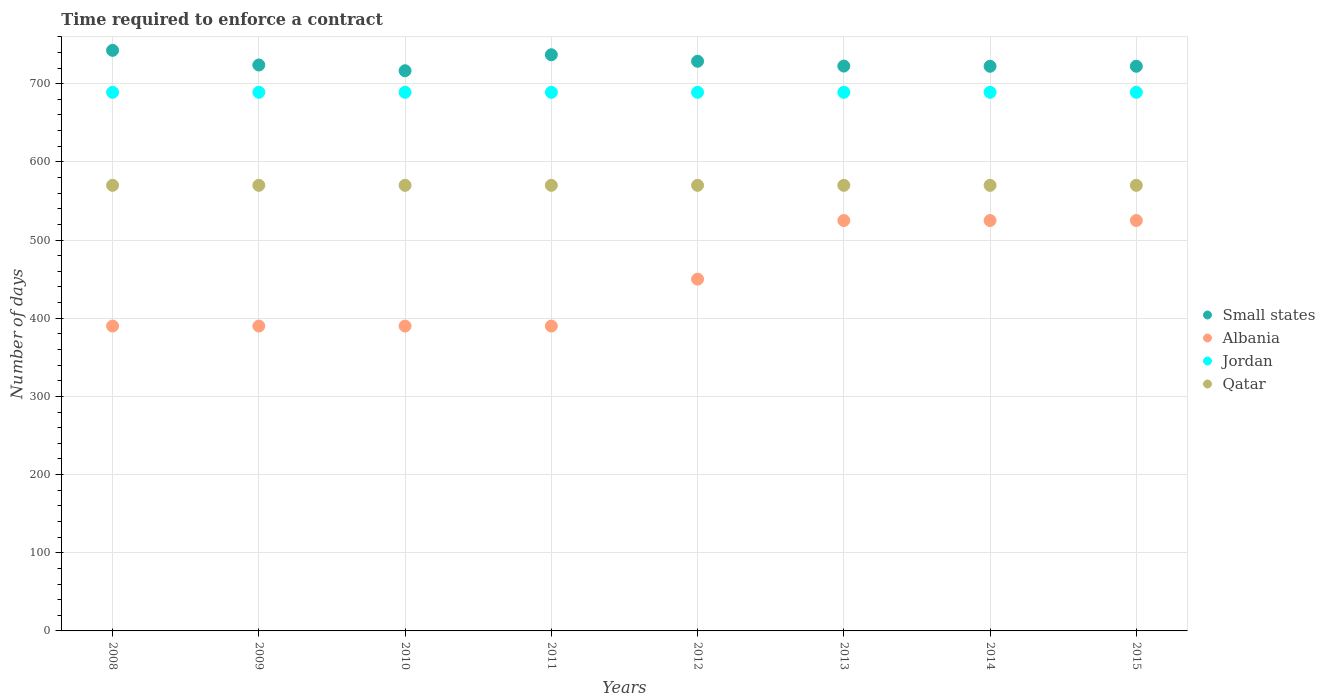How many different coloured dotlines are there?
Offer a terse response. 4. What is the number of days required to enforce a contract in Albania in 2011?
Make the answer very short. 390. Across all years, what is the maximum number of days required to enforce a contract in Jordan?
Provide a short and direct response. 689. Across all years, what is the minimum number of days required to enforce a contract in Qatar?
Your response must be concise. 570. In which year was the number of days required to enforce a contract in Albania minimum?
Offer a very short reply. 2008. What is the total number of days required to enforce a contract in Qatar in the graph?
Offer a terse response. 4560. What is the difference between the number of days required to enforce a contract in Qatar in 2009 and that in 2014?
Keep it short and to the point. 0. What is the difference between the number of days required to enforce a contract in Small states in 2013 and the number of days required to enforce a contract in Jordan in 2009?
Keep it short and to the point. 33.58. What is the average number of days required to enforce a contract in Albania per year?
Give a very brief answer. 448.12. In the year 2009, what is the difference between the number of days required to enforce a contract in Albania and number of days required to enforce a contract in Jordan?
Keep it short and to the point. -299. In how many years, is the number of days required to enforce a contract in Small states greater than 120 days?
Provide a short and direct response. 8. What is the ratio of the number of days required to enforce a contract in Qatar in 2009 to that in 2013?
Give a very brief answer. 1. What is the difference between the highest and the second highest number of days required to enforce a contract in Small states?
Ensure brevity in your answer.  5.62. What is the difference between the highest and the lowest number of days required to enforce a contract in Small states?
Your answer should be very brief. 26.08. In how many years, is the number of days required to enforce a contract in Qatar greater than the average number of days required to enforce a contract in Qatar taken over all years?
Your response must be concise. 0. Does the number of days required to enforce a contract in Jordan monotonically increase over the years?
Your answer should be compact. No. Is the number of days required to enforce a contract in Qatar strictly greater than the number of days required to enforce a contract in Albania over the years?
Offer a very short reply. Yes. How many dotlines are there?
Make the answer very short. 4. What is the difference between two consecutive major ticks on the Y-axis?
Ensure brevity in your answer.  100. Does the graph contain grids?
Your answer should be compact. Yes. Where does the legend appear in the graph?
Provide a short and direct response. Center right. How are the legend labels stacked?
Offer a terse response. Vertical. What is the title of the graph?
Give a very brief answer. Time required to enforce a contract. Does "Cambodia" appear as one of the legend labels in the graph?
Your response must be concise. No. What is the label or title of the X-axis?
Offer a very short reply. Years. What is the label or title of the Y-axis?
Give a very brief answer. Number of days. What is the Number of days of Small states in 2008?
Provide a short and direct response. 742.67. What is the Number of days of Albania in 2008?
Offer a very short reply. 390. What is the Number of days of Jordan in 2008?
Your answer should be compact. 689. What is the Number of days of Qatar in 2008?
Offer a very short reply. 570. What is the Number of days in Small states in 2009?
Give a very brief answer. 723.95. What is the Number of days in Albania in 2009?
Make the answer very short. 390. What is the Number of days in Jordan in 2009?
Provide a succinct answer. 689. What is the Number of days in Qatar in 2009?
Offer a very short reply. 570. What is the Number of days of Small states in 2010?
Offer a terse response. 716.59. What is the Number of days in Albania in 2010?
Keep it short and to the point. 390. What is the Number of days of Jordan in 2010?
Your answer should be very brief. 689. What is the Number of days in Qatar in 2010?
Your response must be concise. 570. What is the Number of days of Small states in 2011?
Your response must be concise. 737.05. What is the Number of days of Albania in 2011?
Make the answer very short. 390. What is the Number of days in Jordan in 2011?
Offer a terse response. 689. What is the Number of days of Qatar in 2011?
Offer a very short reply. 570. What is the Number of days of Small states in 2012?
Your response must be concise. 728.73. What is the Number of days of Albania in 2012?
Provide a succinct answer. 450. What is the Number of days in Jordan in 2012?
Your answer should be very brief. 689. What is the Number of days of Qatar in 2012?
Your response must be concise. 570. What is the Number of days of Small states in 2013?
Keep it short and to the point. 722.58. What is the Number of days in Albania in 2013?
Your response must be concise. 525. What is the Number of days of Jordan in 2013?
Provide a short and direct response. 689. What is the Number of days in Qatar in 2013?
Your answer should be compact. 570. What is the Number of days of Small states in 2014?
Your answer should be very brief. 722.33. What is the Number of days of Albania in 2014?
Offer a very short reply. 525. What is the Number of days of Jordan in 2014?
Your response must be concise. 689. What is the Number of days of Qatar in 2014?
Give a very brief answer. 570. What is the Number of days of Small states in 2015?
Give a very brief answer. 722.33. What is the Number of days of Albania in 2015?
Offer a terse response. 525. What is the Number of days in Jordan in 2015?
Your answer should be compact. 689. What is the Number of days of Qatar in 2015?
Your answer should be compact. 570. Across all years, what is the maximum Number of days of Small states?
Keep it short and to the point. 742.67. Across all years, what is the maximum Number of days in Albania?
Offer a very short reply. 525. Across all years, what is the maximum Number of days in Jordan?
Provide a succinct answer. 689. Across all years, what is the maximum Number of days of Qatar?
Provide a succinct answer. 570. Across all years, what is the minimum Number of days in Small states?
Your answer should be very brief. 716.59. Across all years, what is the minimum Number of days in Albania?
Your answer should be compact. 390. Across all years, what is the minimum Number of days of Jordan?
Provide a short and direct response. 689. Across all years, what is the minimum Number of days of Qatar?
Keep it short and to the point. 570. What is the total Number of days in Small states in the graph?
Make the answer very short. 5816.21. What is the total Number of days in Albania in the graph?
Keep it short and to the point. 3585. What is the total Number of days of Jordan in the graph?
Your response must be concise. 5512. What is the total Number of days in Qatar in the graph?
Provide a succinct answer. 4560. What is the difference between the Number of days of Small states in 2008 and that in 2009?
Offer a very short reply. 18.72. What is the difference between the Number of days of Albania in 2008 and that in 2009?
Provide a short and direct response. 0. What is the difference between the Number of days of Jordan in 2008 and that in 2009?
Ensure brevity in your answer.  0. What is the difference between the Number of days of Qatar in 2008 and that in 2009?
Give a very brief answer. 0. What is the difference between the Number of days in Small states in 2008 and that in 2010?
Your answer should be compact. 26.08. What is the difference between the Number of days in Albania in 2008 and that in 2010?
Ensure brevity in your answer.  0. What is the difference between the Number of days of Jordan in 2008 and that in 2010?
Keep it short and to the point. 0. What is the difference between the Number of days of Qatar in 2008 and that in 2010?
Give a very brief answer. 0. What is the difference between the Number of days of Small states in 2008 and that in 2011?
Provide a succinct answer. 5.62. What is the difference between the Number of days in Albania in 2008 and that in 2011?
Your answer should be compact. 0. What is the difference between the Number of days of Qatar in 2008 and that in 2011?
Your answer should be very brief. 0. What is the difference between the Number of days of Small states in 2008 and that in 2012?
Your answer should be compact. 13.94. What is the difference between the Number of days in Albania in 2008 and that in 2012?
Make the answer very short. -60. What is the difference between the Number of days in Jordan in 2008 and that in 2012?
Your response must be concise. 0. What is the difference between the Number of days in Small states in 2008 and that in 2013?
Your response must be concise. 20.09. What is the difference between the Number of days of Albania in 2008 and that in 2013?
Make the answer very short. -135. What is the difference between the Number of days in Qatar in 2008 and that in 2013?
Offer a very short reply. 0. What is the difference between the Number of days of Small states in 2008 and that in 2014?
Offer a terse response. 20.34. What is the difference between the Number of days of Albania in 2008 and that in 2014?
Your answer should be very brief. -135. What is the difference between the Number of days of Small states in 2008 and that in 2015?
Provide a short and direct response. 20.34. What is the difference between the Number of days of Albania in 2008 and that in 2015?
Offer a very short reply. -135. What is the difference between the Number of days of Jordan in 2008 and that in 2015?
Provide a short and direct response. 0. What is the difference between the Number of days of Qatar in 2008 and that in 2015?
Provide a succinct answer. 0. What is the difference between the Number of days in Small states in 2009 and that in 2010?
Provide a short and direct response. 7.36. What is the difference between the Number of days in Albania in 2009 and that in 2010?
Your response must be concise. 0. What is the difference between the Number of days in Jordan in 2009 and that in 2010?
Your response must be concise. 0. What is the difference between the Number of days in Small states in 2009 and that in 2011?
Keep it short and to the point. -13.1. What is the difference between the Number of days in Albania in 2009 and that in 2011?
Ensure brevity in your answer.  0. What is the difference between the Number of days in Qatar in 2009 and that in 2011?
Provide a succinct answer. 0. What is the difference between the Number of days in Small states in 2009 and that in 2012?
Give a very brief answer. -4.78. What is the difference between the Number of days in Albania in 2009 and that in 2012?
Provide a short and direct response. -60. What is the difference between the Number of days in Small states in 2009 and that in 2013?
Your response must be concise. 1.37. What is the difference between the Number of days in Albania in 2009 and that in 2013?
Your answer should be very brief. -135. What is the difference between the Number of days of Small states in 2009 and that in 2014?
Your answer should be compact. 1.62. What is the difference between the Number of days in Albania in 2009 and that in 2014?
Provide a short and direct response. -135. What is the difference between the Number of days in Qatar in 2009 and that in 2014?
Your answer should be compact. 0. What is the difference between the Number of days in Small states in 2009 and that in 2015?
Keep it short and to the point. 1.62. What is the difference between the Number of days in Albania in 2009 and that in 2015?
Ensure brevity in your answer.  -135. What is the difference between the Number of days of Jordan in 2009 and that in 2015?
Offer a terse response. 0. What is the difference between the Number of days in Qatar in 2009 and that in 2015?
Offer a very short reply. 0. What is the difference between the Number of days of Small states in 2010 and that in 2011?
Give a very brief answer. -20.46. What is the difference between the Number of days in Albania in 2010 and that in 2011?
Keep it short and to the point. 0. What is the difference between the Number of days of Jordan in 2010 and that in 2011?
Give a very brief answer. 0. What is the difference between the Number of days in Qatar in 2010 and that in 2011?
Make the answer very short. 0. What is the difference between the Number of days in Small states in 2010 and that in 2012?
Your answer should be compact. -12.14. What is the difference between the Number of days of Albania in 2010 and that in 2012?
Provide a short and direct response. -60. What is the difference between the Number of days of Jordan in 2010 and that in 2012?
Offer a terse response. 0. What is the difference between the Number of days in Qatar in 2010 and that in 2012?
Your answer should be very brief. 0. What is the difference between the Number of days of Small states in 2010 and that in 2013?
Offer a terse response. -5.99. What is the difference between the Number of days of Albania in 2010 and that in 2013?
Your answer should be compact. -135. What is the difference between the Number of days of Small states in 2010 and that in 2014?
Ensure brevity in your answer.  -5.74. What is the difference between the Number of days in Albania in 2010 and that in 2014?
Your answer should be very brief. -135. What is the difference between the Number of days of Jordan in 2010 and that in 2014?
Keep it short and to the point. 0. What is the difference between the Number of days of Qatar in 2010 and that in 2014?
Your answer should be very brief. 0. What is the difference between the Number of days of Small states in 2010 and that in 2015?
Make the answer very short. -5.74. What is the difference between the Number of days in Albania in 2010 and that in 2015?
Ensure brevity in your answer.  -135. What is the difference between the Number of days in Qatar in 2010 and that in 2015?
Offer a terse response. 0. What is the difference between the Number of days of Small states in 2011 and that in 2012?
Give a very brief answer. 8.32. What is the difference between the Number of days of Albania in 2011 and that in 2012?
Make the answer very short. -60. What is the difference between the Number of days of Qatar in 2011 and that in 2012?
Your response must be concise. 0. What is the difference between the Number of days in Small states in 2011 and that in 2013?
Your response must be concise. 14.47. What is the difference between the Number of days of Albania in 2011 and that in 2013?
Your response must be concise. -135. What is the difference between the Number of days of Jordan in 2011 and that in 2013?
Your answer should be very brief. 0. What is the difference between the Number of days of Qatar in 2011 and that in 2013?
Give a very brief answer. 0. What is the difference between the Number of days in Small states in 2011 and that in 2014?
Your response must be concise. 14.72. What is the difference between the Number of days of Albania in 2011 and that in 2014?
Offer a very short reply. -135. What is the difference between the Number of days in Jordan in 2011 and that in 2014?
Give a very brief answer. 0. What is the difference between the Number of days of Small states in 2011 and that in 2015?
Your answer should be very brief. 14.72. What is the difference between the Number of days in Albania in 2011 and that in 2015?
Make the answer very short. -135. What is the difference between the Number of days of Jordan in 2011 and that in 2015?
Provide a succinct answer. 0. What is the difference between the Number of days of Qatar in 2011 and that in 2015?
Make the answer very short. 0. What is the difference between the Number of days in Small states in 2012 and that in 2013?
Provide a short and direct response. 6.15. What is the difference between the Number of days in Albania in 2012 and that in 2013?
Offer a very short reply. -75. What is the difference between the Number of days of Small states in 2012 and that in 2014?
Provide a short and direct response. 6.4. What is the difference between the Number of days in Albania in 2012 and that in 2014?
Ensure brevity in your answer.  -75. What is the difference between the Number of days in Jordan in 2012 and that in 2014?
Your answer should be very brief. 0. What is the difference between the Number of days in Qatar in 2012 and that in 2014?
Ensure brevity in your answer.  0. What is the difference between the Number of days in Albania in 2012 and that in 2015?
Your response must be concise. -75. What is the difference between the Number of days in Jordan in 2013 and that in 2014?
Give a very brief answer. 0. What is the difference between the Number of days in Qatar in 2013 and that in 2014?
Provide a succinct answer. 0. What is the difference between the Number of days in Small states in 2013 and that in 2015?
Your answer should be very brief. 0.25. What is the difference between the Number of days in Qatar in 2013 and that in 2015?
Keep it short and to the point. 0. What is the difference between the Number of days of Small states in 2014 and that in 2015?
Offer a terse response. 0. What is the difference between the Number of days in Jordan in 2014 and that in 2015?
Your answer should be compact. 0. What is the difference between the Number of days of Qatar in 2014 and that in 2015?
Provide a succinct answer. 0. What is the difference between the Number of days of Small states in 2008 and the Number of days of Albania in 2009?
Your response must be concise. 352.67. What is the difference between the Number of days in Small states in 2008 and the Number of days in Jordan in 2009?
Make the answer very short. 53.67. What is the difference between the Number of days of Small states in 2008 and the Number of days of Qatar in 2009?
Provide a succinct answer. 172.67. What is the difference between the Number of days of Albania in 2008 and the Number of days of Jordan in 2009?
Your response must be concise. -299. What is the difference between the Number of days of Albania in 2008 and the Number of days of Qatar in 2009?
Keep it short and to the point. -180. What is the difference between the Number of days in Jordan in 2008 and the Number of days in Qatar in 2009?
Make the answer very short. 119. What is the difference between the Number of days in Small states in 2008 and the Number of days in Albania in 2010?
Provide a short and direct response. 352.67. What is the difference between the Number of days in Small states in 2008 and the Number of days in Jordan in 2010?
Provide a short and direct response. 53.67. What is the difference between the Number of days in Small states in 2008 and the Number of days in Qatar in 2010?
Offer a very short reply. 172.67. What is the difference between the Number of days in Albania in 2008 and the Number of days in Jordan in 2010?
Your answer should be very brief. -299. What is the difference between the Number of days in Albania in 2008 and the Number of days in Qatar in 2010?
Ensure brevity in your answer.  -180. What is the difference between the Number of days of Jordan in 2008 and the Number of days of Qatar in 2010?
Your answer should be very brief. 119. What is the difference between the Number of days in Small states in 2008 and the Number of days in Albania in 2011?
Offer a very short reply. 352.67. What is the difference between the Number of days of Small states in 2008 and the Number of days of Jordan in 2011?
Your response must be concise. 53.67. What is the difference between the Number of days of Small states in 2008 and the Number of days of Qatar in 2011?
Provide a short and direct response. 172.67. What is the difference between the Number of days in Albania in 2008 and the Number of days in Jordan in 2011?
Your answer should be compact. -299. What is the difference between the Number of days in Albania in 2008 and the Number of days in Qatar in 2011?
Your answer should be very brief. -180. What is the difference between the Number of days in Jordan in 2008 and the Number of days in Qatar in 2011?
Give a very brief answer. 119. What is the difference between the Number of days of Small states in 2008 and the Number of days of Albania in 2012?
Give a very brief answer. 292.67. What is the difference between the Number of days in Small states in 2008 and the Number of days in Jordan in 2012?
Provide a succinct answer. 53.67. What is the difference between the Number of days of Small states in 2008 and the Number of days of Qatar in 2012?
Offer a terse response. 172.67. What is the difference between the Number of days in Albania in 2008 and the Number of days in Jordan in 2012?
Your answer should be compact. -299. What is the difference between the Number of days in Albania in 2008 and the Number of days in Qatar in 2012?
Keep it short and to the point. -180. What is the difference between the Number of days in Jordan in 2008 and the Number of days in Qatar in 2012?
Your answer should be very brief. 119. What is the difference between the Number of days in Small states in 2008 and the Number of days in Albania in 2013?
Your answer should be compact. 217.67. What is the difference between the Number of days of Small states in 2008 and the Number of days of Jordan in 2013?
Make the answer very short. 53.67. What is the difference between the Number of days of Small states in 2008 and the Number of days of Qatar in 2013?
Provide a succinct answer. 172.67. What is the difference between the Number of days in Albania in 2008 and the Number of days in Jordan in 2013?
Offer a terse response. -299. What is the difference between the Number of days of Albania in 2008 and the Number of days of Qatar in 2013?
Offer a terse response. -180. What is the difference between the Number of days of Jordan in 2008 and the Number of days of Qatar in 2013?
Offer a terse response. 119. What is the difference between the Number of days of Small states in 2008 and the Number of days of Albania in 2014?
Provide a short and direct response. 217.67. What is the difference between the Number of days in Small states in 2008 and the Number of days in Jordan in 2014?
Offer a terse response. 53.67. What is the difference between the Number of days in Small states in 2008 and the Number of days in Qatar in 2014?
Your answer should be very brief. 172.67. What is the difference between the Number of days of Albania in 2008 and the Number of days of Jordan in 2014?
Your answer should be compact. -299. What is the difference between the Number of days in Albania in 2008 and the Number of days in Qatar in 2014?
Offer a terse response. -180. What is the difference between the Number of days in Jordan in 2008 and the Number of days in Qatar in 2014?
Your answer should be compact. 119. What is the difference between the Number of days of Small states in 2008 and the Number of days of Albania in 2015?
Your response must be concise. 217.67. What is the difference between the Number of days in Small states in 2008 and the Number of days in Jordan in 2015?
Make the answer very short. 53.67. What is the difference between the Number of days of Small states in 2008 and the Number of days of Qatar in 2015?
Your answer should be very brief. 172.67. What is the difference between the Number of days of Albania in 2008 and the Number of days of Jordan in 2015?
Your answer should be very brief. -299. What is the difference between the Number of days of Albania in 2008 and the Number of days of Qatar in 2015?
Keep it short and to the point. -180. What is the difference between the Number of days in Jordan in 2008 and the Number of days in Qatar in 2015?
Keep it short and to the point. 119. What is the difference between the Number of days of Small states in 2009 and the Number of days of Albania in 2010?
Keep it short and to the point. 333.95. What is the difference between the Number of days of Small states in 2009 and the Number of days of Jordan in 2010?
Offer a very short reply. 34.95. What is the difference between the Number of days in Small states in 2009 and the Number of days in Qatar in 2010?
Your response must be concise. 153.95. What is the difference between the Number of days in Albania in 2009 and the Number of days in Jordan in 2010?
Provide a succinct answer. -299. What is the difference between the Number of days in Albania in 2009 and the Number of days in Qatar in 2010?
Your answer should be very brief. -180. What is the difference between the Number of days in Jordan in 2009 and the Number of days in Qatar in 2010?
Ensure brevity in your answer.  119. What is the difference between the Number of days in Small states in 2009 and the Number of days in Albania in 2011?
Your response must be concise. 333.95. What is the difference between the Number of days in Small states in 2009 and the Number of days in Jordan in 2011?
Your answer should be very brief. 34.95. What is the difference between the Number of days in Small states in 2009 and the Number of days in Qatar in 2011?
Make the answer very short. 153.95. What is the difference between the Number of days in Albania in 2009 and the Number of days in Jordan in 2011?
Provide a short and direct response. -299. What is the difference between the Number of days in Albania in 2009 and the Number of days in Qatar in 2011?
Make the answer very short. -180. What is the difference between the Number of days of Jordan in 2009 and the Number of days of Qatar in 2011?
Your response must be concise. 119. What is the difference between the Number of days in Small states in 2009 and the Number of days in Albania in 2012?
Ensure brevity in your answer.  273.95. What is the difference between the Number of days in Small states in 2009 and the Number of days in Jordan in 2012?
Your response must be concise. 34.95. What is the difference between the Number of days in Small states in 2009 and the Number of days in Qatar in 2012?
Offer a terse response. 153.95. What is the difference between the Number of days in Albania in 2009 and the Number of days in Jordan in 2012?
Provide a succinct answer. -299. What is the difference between the Number of days in Albania in 2009 and the Number of days in Qatar in 2012?
Give a very brief answer. -180. What is the difference between the Number of days of Jordan in 2009 and the Number of days of Qatar in 2012?
Your answer should be compact. 119. What is the difference between the Number of days of Small states in 2009 and the Number of days of Albania in 2013?
Offer a very short reply. 198.95. What is the difference between the Number of days in Small states in 2009 and the Number of days in Jordan in 2013?
Provide a succinct answer. 34.95. What is the difference between the Number of days of Small states in 2009 and the Number of days of Qatar in 2013?
Your response must be concise. 153.95. What is the difference between the Number of days of Albania in 2009 and the Number of days of Jordan in 2013?
Your response must be concise. -299. What is the difference between the Number of days of Albania in 2009 and the Number of days of Qatar in 2013?
Provide a succinct answer. -180. What is the difference between the Number of days of Jordan in 2009 and the Number of days of Qatar in 2013?
Ensure brevity in your answer.  119. What is the difference between the Number of days of Small states in 2009 and the Number of days of Albania in 2014?
Offer a terse response. 198.95. What is the difference between the Number of days of Small states in 2009 and the Number of days of Jordan in 2014?
Ensure brevity in your answer.  34.95. What is the difference between the Number of days of Small states in 2009 and the Number of days of Qatar in 2014?
Keep it short and to the point. 153.95. What is the difference between the Number of days of Albania in 2009 and the Number of days of Jordan in 2014?
Give a very brief answer. -299. What is the difference between the Number of days in Albania in 2009 and the Number of days in Qatar in 2014?
Offer a terse response. -180. What is the difference between the Number of days in Jordan in 2009 and the Number of days in Qatar in 2014?
Your answer should be very brief. 119. What is the difference between the Number of days of Small states in 2009 and the Number of days of Albania in 2015?
Offer a terse response. 198.95. What is the difference between the Number of days in Small states in 2009 and the Number of days in Jordan in 2015?
Make the answer very short. 34.95. What is the difference between the Number of days in Small states in 2009 and the Number of days in Qatar in 2015?
Make the answer very short. 153.95. What is the difference between the Number of days in Albania in 2009 and the Number of days in Jordan in 2015?
Your response must be concise. -299. What is the difference between the Number of days of Albania in 2009 and the Number of days of Qatar in 2015?
Offer a terse response. -180. What is the difference between the Number of days in Jordan in 2009 and the Number of days in Qatar in 2015?
Offer a very short reply. 119. What is the difference between the Number of days in Small states in 2010 and the Number of days in Albania in 2011?
Your answer should be very brief. 326.59. What is the difference between the Number of days in Small states in 2010 and the Number of days in Jordan in 2011?
Offer a terse response. 27.59. What is the difference between the Number of days in Small states in 2010 and the Number of days in Qatar in 2011?
Make the answer very short. 146.59. What is the difference between the Number of days in Albania in 2010 and the Number of days in Jordan in 2011?
Offer a terse response. -299. What is the difference between the Number of days in Albania in 2010 and the Number of days in Qatar in 2011?
Keep it short and to the point. -180. What is the difference between the Number of days in Jordan in 2010 and the Number of days in Qatar in 2011?
Keep it short and to the point. 119. What is the difference between the Number of days of Small states in 2010 and the Number of days of Albania in 2012?
Your response must be concise. 266.59. What is the difference between the Number of days of Small states in 2010 and the Number of days of Jordan in 2012?
Ensure brevity in your answer.  27.59. What is the difference between the Number of days of Small states in 2010 and the Number of days of Qatar in 2012?
Ensure brevity in your answer.  146.59. What is the difference between the Number of days of Albania in 2010 and the Number of days of Jordan in 2012?
Offer a terse response. -299. What is the difference between the Number of days of Albania in 2010 and the Number of days of Qatar in 2012?
Give a very brief answer. -180. What is the difference between the Number of days in Jordan in 2010 and the Number of days in Qatar in 2012?
Provide a succinct answer. 119. What is the difference between the Number of days in Small states in 2010 and the Number of days in Albania in 2013?
Keep it short and to the point. 191.59. What is the difference between the Number of days in Small states in 2010 and the Number of days in Jordan in 2013?
Give a very brief answer. 27.59. What is the difference between the Number of days of Small states in 2010 and the Number of days of Qatar in 2013?
Your response must be concise. 146.59. What is the difference between the Number of days in Albania in 2010 and the Number of days in Jordan in 2013?
Provide a succinct answer. -299. What is the difference between the Number of days in Albania in 2010 and the Number of days in Qatar in 2013?
Keep it short and to the point. -180. What is the difference between the Number of days of Jordan in 2010 and the Number of days of Qatar in 2013?
Your answer should be very brief. 119. What is the difference between the Number of days of Small states in 2010 and the Number of days of Albania in 2014?
Offer a very short reply. 191.59. What is the difference between the Number of days in Small states in 2010 and the Number of days in Jordan in 2014?
Offer a terse response. 27.59. What is the difference between the Number of days in Small states in 2010 and the Number of days in Qatar in 2014?
Your response must be concise. 146.59. What is the difference between the Number of days of Albania in 2010 and the Number of days of Jordan in 2014?
Give a very brief answer. -299. What is the difference between the Number of days in Albania in 2010 and the Number of days in Qatar in 2014?
Your answer should be compact. -180. What is the difference between the Number of days of Jordan in 2010 and the Number of days of Qatar in 2014?
Make the answer very short. 119. What is the difference between the Number of days in Small states in 2010 and the Number of days in Albania in 2015?
Offer a terse response. 191.59. What is the difference between the Number of days of Small states in 2010 and the Number of days of Jordan in 2015?
Make the answer very short. 27.59. What is the difference between the Number of days of Small states in 2010 and the Number of days of Qatar in 2015?
Provide a succinct answer. 146.59. What is the difference between the Number of days in Albania in 2010 and the Number of days in Jordan in 2015?
Your response must be concise. -299. What is the difference between the Number of days in Albania in 2010 and the Number of days in Qatar in 2015?
Ensure brevity in your answer.  -180. What is the difference between the Number of days in Jordan in 2010 and the Number of days in Qatar in 2015?
Your response must be concise. 119. What is the difference between the Number of days of Small states in 2011 and the Number of days of Albania in 2012?
Make the answer very short. 287.05. What is the difference between the Number of days in Small states in 2011 and the Number of days in Jordan in 2012?
Provide a succinct answer. 48.05. What is the difference between the Number of days in Small states in 2011 and the Number of days in Qatar in 2012?
Your answer should be very brief. 167.05. What is the difference between the Number of days of Albania in 2011 and the Number of days of Jordan in 2012?
Offer a terse response. -299. What is the difference between the Number of days of Albania in 2011 and the Number of days of Qatar in 2012?
Provide a short and direct response. -180. What is the difference between the Number of days in Jordan in 2011 and the Number of days in Qatar in 2012?
Provide a short and direct response. 119. What is the difference between the Number of days in Small states in 2011 and the Number of days in Albania in 2013?
Provide a succinct answer. 212.05. What is the difference between the Number of days of Small states in 2011 and the Number of days of Jordan in 2013?
Keep it short and to the point. 48.05. What is the difference between the Number of days of Small states in 2011 and the Number of days of Qatar in 2013?
Your answer should be very brief. 167.05. What is the difference between the Number of days in Albania in 2011 and the Number of days in Jordan in 2013?
Your answer should be very brief. -299. What is the difference between the Number of days in Albania in 2011 and the Number of days in Qatar in 2013?
Ensure brevity in your answer.  -180. What is the difference between the Number of days of Jordan in 2011 and the Number of days of Qatar in 2013?
Your answer should be compact. 119. What is the difference between the Number of days of Small states in 2011 and the Number of days of Albania in 2014?
Offer a terse response. 212.05. What is the difference between the Number of days of Small states in 2011 and the Number of days of Jordan in 2014?
Your answer should be very brief. 48.05. What is the difference between the Number of days in Small states in 2011 and the Number of days in Qatar in 2014?
Keep it short and to the point. 167.05. What is the difference between the Number of days in Albania in 2011 and the Number of days in Jordan in 2014?
Offer a very short reply. -299. What is the difference between the Number of days in Albania in 2011 and the Number of days in Qatar in 2014?
Keep it short and to the point. -180. What is the difference between the Number of days of Jordan in 2011 and the Number of days of Qatar in 2014?
Give a very brief answer. 119. What is the difference between the Number of days of Small states in 2011 and the Number of days of Albania in 2015?
Offer a terse response. 212.05. What is the difference between the Number of days in Small states in 2011 and the Number of days in Jordan in 2015?
Provide a succinct answer. 48.05. What is the difference between the Number of days of Small states in 2011 and the Number of days of Qatar in 2015?
Your answer should be compact. 167.05. What is the difference between the Number of days in Albania in 2011 and the Number of days in Jordan in 2015?
Your response must be concise. -299. What is the difference between the Number of days in Albania in 2011 and the Number of days in Qatar in 2015?
Give a very brief answer. -180. What is the difference between the Number of days in Jordan in 2011 and the Number of days in Qatar in 2015?
Your answer should be very brief. 119. What is the difference between the Number of days in Small states in 2012 and the Number of days in Albania in 2013?
Make the answer very short. 203.72. What is the difference between the Number of days of Small states in 2012 and the Number of days of Jordan in 2013?
Make the answer very short. 39.73. What is the difference between the Number of days in Small states in 2012 and the Number of days in Qatar in 2013?
Your answer should be very brief. 158.72. What is the difference between the Number of days of Albania in 2012 and the Number of days of Jordan in 2013?
Provide a succinct answer. -239. What is the difference between the Number of days in Albania in 2012 and the Number of days in Qatar in 2013?
Make the answer very short. -120. What is the difference between the Number of days in Jordan in 2012 and the Number of days in Qatar in 2013?
Give a very brief answer. 119. What is the difference between the Number of days of Small states in 2012 and the Number of days of Albania in 2014?
Keep it short and to the point. 203.72. What is the difference between the Number of days in Small states in 2012 and the Number of days in Jordan in 2014?
Give a very brief answer. 39.73. What is the difference between the Number of days of Small states in 2012 and the Number of days of Qatar in 2014?
Offer a terse response. 158.72. What is the difference between the Number of days in Albania in 2012 and the Number of days in Jordan in 2014?
Your answer should be very brief. -239. What is the difference between the Number of days of Albania in 2012 and the Number of days of Qatar in 2014?
Offer a very short reply. -120. What is the difference between the Number of days of Jordan in 2012 and the Number of days of Qatar in 2014?
Offer a terse response. 119. What is the difference between the Number of days in Small states in 2012 and the Number of days in Albania in 2015?
Give a very brief answer. 203.72. What is the difference between the Number of days of Small states in 2012 and the Number of days of Jordan in 2015?
Your answer should be compact. 39.73. What is the difference between the Number of days of Small states in 2012 and the Number of days of Qatar in 2015?
Your answer should be very brief. 158.72. What is the difference between the Number of days of Albania in 2012 and the Number of days of Jordan in 2015?
Give a very brief answer. -239. What is the difference between the Number of days of Albania in 2012 and the Number of days of Qatar in 2015?
Offer a very short reply. -120. What is the difference between the Number of days in Jordan in 2012 and the Number of days in Qatar in 2015?
Make the answer very short. 119. What is the difference between the Number of days in Small states in 2013 and the Number of days in Albania in 2014?
Provide a short and direct response. 197.57. What is the difference between the Number of days in Small states in 2013 and the Number of days in Jordan in 2014?
Provide a succinct answer. 33.58. What is the difference between the Number of days of Small states in 2013 and the Number of days of Qatar in 2014?
Make the answer very short. 152.57. What is the difference between the Number of days of Albania in 2013 and the Number of days of Jordan in 2014?
Your answer should be compact. -164. What is the difference between the Number of days in Albania in 2013 and the Number of days in Qatar in 2014?
Your response must be concise. -45. What is the difference between the Number of days of Jordan in 2013 and the Number of days of Qatar in 2014?
Offer a terse response. 119. What is the difference between the Number of days in Small states in 2013 and the Number of days in Albania in 2015?
Make the answer very short. 197.57. What is the difference between the Number of days of Small states in 2013 and the Number of days of Jordan in 2015?
Provide a succinct answer. 33.58. What is the difference between the Number of days in Small states in 2013 and the Number of days in Qatar in 2015?
Make the answer very short. 152.57. What is the difference between the Number of days in Albania in 2013 and the Number of days in Jordan in 2015?
Provide a short and direct response. -164. What is the difference between the Number of days of Albania in 2013 and the Number of days of Qatar in 2015?
Make the answer very short. -45. What is the difference between the Number of days in Jordan in 2013 and the Number of days in Qatar in 2015?
Your answer should be compact. 119. What is the difference between the Number of days in Small states in 2014 and the Number of days in Albania in 2015?
Offer a very short reply. 197.32. What is the difference between the Number of days in Small states in 2014 and the Number of days in Jordan in 2015?
Provide a short and direct response. 33.33. What is the difference between the Number of days of Small states in 2014 and the Number of days of Qatar in 2015?
Offer a terse response. 152.32. What is the difference between the Number of days in Albania in 2014 and the Number of days in Jordan in 2015?
Make the answer very short. -164. What is the difference between the Number of days in Albania in 2014 and the Number of days in Qatar in 2015?
Your answer should be compact. -45. What is the difference between the Number of days of Jordan in 2014 and the Number of days of Qatar in 2015?
Ensure brevity in your answer.  119. What is the average Number of days in Small states per year?
Provide a short and direct response. 727.03. What is the average Number of days of Albania per year?
Make the answer very short. 448.12. What is the average Number of days in Jordan per year?
Provide a succinct answer. 689. What is the average Number of days in Qatar per year?
Your answer should be very brief. 570. In the year 2008, what is the difference between the Number of days of Small states and Number of days of Albania?
Your response must be concise. 352.67. In the year 2008, what is the difference between the Number of days in Small states and Number of days in Jordan?
Provide a short and direct response. 53.67. In the year 2008, what is the difference between the Number of days in Small states and Number of days in Qatar?
Ensure brevity in your answer.  172.67. In the year 2008, what is the difference between the Number of days in Albania and Number of days in Jordan?
Your answer should be compact. -299. In the year 2008, what is the difference between the Number of days in Albania and Number of days in Qatar?
Make the answer very short. -180. In the year 2008, what is the difference between the Number of days of Jordan and Number of days of Qatar?
Provide a succinct answer. 119. In the year 2009, what is the difference between the Number of days of Small states and Number of days of Albania?
Offer a terse response. 333.95. In the year 2009, what is the difference between the Number of days in Small states and Number of days in Jordan?
Make the answer very short. 34.95. In the year 2009, what is the difference between the Number of days of Small states and Number of days of Qatar?
Give a very brief answer. 153.95. In the year 2009, what is the difference between the Number of days of Albania and Number of days of Jordan?
Your response must be concise. -299. In the year 2009, what is the difference between the Number of days of Albania and Number of days of Qatar?
Ensure brevity in your answer.  -180. In the year 2009, what is the difference between the Number of days of Jordan and Number of days of Qatar?
Your response must be concise. 119. In the year 2010, what is the difference between the Number of days in Small states and Number of days in Albania?
Provide a short and direct response. 326.59. In the year 2010, what is the difference between the Number of days in Small states and Number of days in Jordan?
Ensure brevity in your answer.  27.59. In the year 2010, what is the difference between the Number of days of Small states and Number of days of Qatar?
Your answer should be compact. 146.59. In the year 2010, what is the difference between the Number of days of Albania and Number of days of Jordan?
Your response must be concise. -299. In the year 2010, what is the difference between the Number of days in Albania and Number of days in Qatar?
Make the answer very short. -180. In the year 2010, what is the difference between the Number of days of Jordan and Number of days of Qatar?
Provide a short and direct response. 119. In the year 2011, what is the difference between the Number of days of Small states and Number of days of Albania?
Ensure brevity in your answer.  347.05. In the year 2011, what is the difference between the Number of days in Small states and Number of days in Jordan?
Make the answer very short. 48.05. In the year 2011, what is the difference between the Number of days in Small states and Number of days in Qatar?
Give a very brief answer. 167.05. In the year 2011, what is the difference between the Number of days of Albania and Number of days of Jordan?
Provide a succinct answer. -299. In the year 2011, what is the difference between the Number of days of Albania and Number of days of Qatar?
Your response must be concise. -180. In the year 2011, what is the difference between the Number of days of Jordan and Number of days of Qatar?
Provide a succinct answer. 119. In the year 2012, what is the difference between the Number of days in Small states and Number of days in Albania?
Provide a succinct answer. 278.73. In the year 2012, what is the difference between the Number of days of Small states and Number of days of Jordan?
Make the answer very short. 39.73. In the year 2012, what is the difference between the Number of days of Small states and Number of days of Qatar?
Offer a terse response. 158.72. In the year 2012, what is the difference between the Number of days in Albania and Number of days in Jordan?
Offer a very short reply. -239. In the year 2012, what is the difference between the Number of days of Albania and Number of days of Qatar?
Your response must be concise. -120. In the year 2012, what is the difference between the Number of days of Jordan and Number of days of Qatar?
Keep it short and to the point. 119. In the year 2013, what is the difference between the Number of days in Small states and Number of days in Albania?
Make the answer very short. 197.57. In the year 2013, what is the difference between the Number of days in Small states and Number of days in Jordan?
Offer a terse response. 33.58. In the year 2013, what is the difference between the Number of days in Small states and Number of days in Qatar?
Make the answer very short. 152.57. In the year 2013, what is the difference between the Number of days of Albania and Number of days of Jordan?
Your answer should be compact. -164. In the year 2013, what is the difference between the Number of days in Albania and Number of days in Qatar?
Provide a short and direct response. -45. In the year 2013, what is the difference between the Number of days in Jordan and Number of days in Qatar?
Offer a terse response. 119. In the year 2014, what is the difference between the Number of days of Small states and Number of days of Albania?
Keep it short and to the point. 197.32. In the year 2014, what is the difference between the Number of days of Small states and Number of days of Jordan?
Give a very brief answer. 33.33. In the year 2014, what is the difference between the Number of days of Small states and Number of days of Qatar?
Your response must be concise. 152.32. In the year 2014, what is the difference between the Number of days in Albania and Number of days in Jordan?
Offer a very short reply. -164. In the year 2014, what is the difference between the Number of days of Albania and Number of days of Qatar?
Give a very brief answer. -45. In the year 2014, what is the difference between the Number of days in Jordan and Number of days in Qatar?
Offer a very short reply. 119. In the year 2015, what is the difference between the Number of days in Small states and Number of days in Albania?
Offer a terse response. 197.32. In the year 2015, what is the difference between the Number of days of Small states and Number of days of Jordan?
Offer a very short reply. 33.33. In the year 2015, what is the difference between the Number of days of Small states and Number of days of Qatar?
Give a very brief answer. 152.32. In the year 2015, what is the difference between the Number of days of Albania and Number of days of Jordan?
Ensure brevity in your answer.  -164. In the year 2015, what is the difference between the Number of days in Albania and Number of days in Qatar?
Provide a short and direct response. -45. In the year 2015, what is the difference between the Number of days in Jordan and Number of days in Qatar?
Your answer should be very brief. 119. What is the ratio of the Number of days in Small states in 2008 to that in 2009?
Give a very brief answer. 1.03. What is the ratio of the Number of days of Jordan in 2008 to that in 2009?
Provide a succinct answer. 1. What is the ratio of the Number of days of Small states in 2008 to that in 2010?
Your answer should be compact. 1.04. What is the ratio of the Number of days in Albania in 2008 to that in 2010?
Offer a terse response. 1. What is the ratio of the Number of days in Qatar in 2008 to that in 2010?
Your answer should be compact. 1. What is the ratio of the Number of days of Small states in 2008 to that in 2011?
Your answer should be compact. 1.01. What is the ratio of the Number of days of Albania in 2008 to that in 2011?
Provide a succinct answer. 1. What is the ratio of the Number of days in Qatar in 2008 to that in 2011?
Your answer should be very brief. 1. What is the ratio of the Number of days in Small states in 2008 to that in 2012?
Your answer should be compact. 1.02. What is the ratio of the Number of days of Albania in 2008 to that in 2012?
Keep it short and to the point. 0.87. What is the ratio of the Number of days of Small states in 2008 to that in 2013?
Offer a very short reply. 1.03. What is the ratio of the Number of days of Albania in 2008 to that in 2013?
Keep it short and to the point. 0.74. What is the ratio of the Number of days in Small states in 2008 to that in 2014?
Offer a very short reply. 1.03. What is the ratio of the Number of days of Albania in 2008 to that in 2014?
Offer a very short reply. 0.74. What is the ratio of the Number of days of Qatar in 2008 to that in 2014?
Make the answer very short. 1. What is the ratio of the Number of days in Small states in 2008 to that in 2015?
Your answer should be very brief. 1.03. What is the ratio of the Number of days of Albania in 2008 to that in 2015?
Provide a short and direct response. 0.74. What is the ratio of the Number of days in Jordan in 2008 to that in 2015?
Your answer should be very brief. 1. What is the ratio of the Number of days in Small states in 2009 to that in 2010?
Your answer should be compact. 1.01. What is the ratio of the Number of days of Albania in 2009 to that in 2010?
Give a very brief answer. 1. What is the ratio of the Number of days in Jordan in 2009 to that in 2010?
Give a very brief answer. 1. What is the ratio of the Number of days of Small states in 2009 to that in 2011?
Keep it short and to the point. 0.98. What is the ratio of the Number of days of Small states in 2009 to that in 2012?
Offer a terse response. 0.99. What is the ratio of the Number of days in Albania in 2009 to that in 2012?
Your response must be concise. 0.87. What is the ratio of the Number of days of Qatar in 2009 to that in 2012?
Keep it short and to the point. 1. What is the ratio of the Number of days of Small states in 2009 to that in 2013?
Make the answer very short. 1. What is the ratio of the Number of days of Albania in 2009 to that in 2013?
Your answer should be compact. 0.74. What is the ratio of the Number of days in Jordan in 2009 to that in 2013?
Your response must be concise. 1. What is the ratio of the Number of days of Qatar in 2009 to that in 2013?
Offer a terse response. 1. What is the ratio of the Number of days in Albania in 2009 to that in 2014?
Provide a short and direct response. 0.74. What is the ratio of the Number of days of Jordan in 2009 to that in 2014?
Your answer should be very brief. 1. What is the ratio of the Number of days in Small states in 2009 to that in 2015?
Keep it short and to the point. 1. What is the ratio of the Number of days of Albania in 2009 to that in 2015?
Provide a short and direct response. 0.74. What is the ratio of the Number of days in Small states in 2010 to that in 2011?
Provide a succinct answer. 0.97. What is the ratio of the Number of days of Jordan in 2010 to that in 2011?
Your answer should be compact. 1. What is the ratio of the Number of days in Qatar in 2010 to that in 2011?
Offer a very short reply. 1. What is the ratio of the Number of days in Small states in 2010 to that in 2012?
Your answer should be compact. 0.98. What is the ratio of the Number of days in Albania in 2010 to that in 2012?
Make the answer very short. 0.87. What is the ratio of the Number of days in Jordan in 2010 to that in 2012?
Give a very brief answer. 1. What is the ratio of the Number of days in Qatar in 2010 to that in 2012?
Provide a short and direct response. 1. What is the ratio of the Number of days in Small states in 2010 to that in 2013?
Offer a very short reply. 0.99. What is the ratio of the Number of days of Albania in 2010 to that in 2013?
Your answer should be very brief. 0.74. What is the ratio of the Number of days of Jordan in 2010 to that in 2013?
Your response must be concise. 1. What is the ratio of the Number of days in Qatar in 2010 to that in 2013?
Give a very brief answer. 1. What is the ratio of the Number of days of Albania in 2010 to that in 2014?
Offer a very short reply. 0.74. What is the ratio of the Number of days in Qatar in 2010 to that in 2014?
Your answer should be compact. 1. What is the ratio of the Number of days of Albania in 2010 to that in 2015?
Give a very brief answer. 0.74. What is the ratio of the Number of days of Jordan in 2010 to that in 2015?
Give a very brief answer. 1. What is the ratio of the Number of days of Small states in 2011 to that in 2012?
Give a very brief answer. 1.01. What is the ratio of the Number of days in Albania in 2011 to that in 2012?
Provide a short and direct response. 0.87. What is the ratio of the Number of days in Jordan in 2011 to that in 2012?
Provide a succinct answer. 1. What is the ratio of the Number of days in Qatar in 2011 to that in 2012?
Your answer should be compact. 1. What is the ratio of the Number of days in Albania in 2011 to that in 2013?
Offer a terse response. 0.74. What is the ratio of the Number of days in Jordan in 2011 to that in 2013?
Your answer should be compact. 1. What is the ratio of the Number of days in Qatar in 2011 to that in 2013?
Your answer should be compact. 1. What is the ratio of the Number of days of Small states in 2011 to that in 2014?
Make the answer very short. 1.02. What is the ratio of the Number of days of Albania in 2011 to that in 2014?
Make the answer very short. 0.74. What is the ratio of the Number of days in Qatar in 2011 to that in 2014?
Provide a succinct answer. 1. What is the ratio of the Number of days in Small states in 2011 to that in 2015?
Your answer should be very brief. 1.02. What is the ratio of the Number of days of Albania in 2011 to that in 2015?
Keep it short and to the point. 0.74. What is the ratio of the Number of days in Qatar in 2011 to that in 2015?
Offer a terse response. 1. What is the ratio of the Number of days of Small states in 2012 to that in 2013?
Give a very brief answer. 1.01. What is the ratio of the Number of days in Qatar in 2012 to that in 2013?
Give a very brief answer. 1. What is the ratio of the Number of days of Small states in 2012 to that in 2014?
Provide a short and direct response. 1.01. What is the ratio of the Number of days of Albania in 2012 to that in 2014?
Offer a very short reply. 0.86. What is the ratio of the Number of days in Qatar in 2012 to that in 2014?
Provide a succinct answer. 1. What is the ratio of the Number of days of Small states in 2012 to that in 2015?
Your answer should be very brief. 1.01. What is the ratio of the Number of days of Qatar in 2012 to that in 2015?
Offer a very short reply. 1. What is the ratio of the Number of days in Small states in 2013 to that in 2014?
Keep it short and to the point. 1. What is the ratio of the Number of days in Jordan in 2013 to that in 2014?
Keep it short and to the point. 1. What is the ratio of the Number of days of Qatar in 2013 to that in 2014?
Offer a very short reply. 1. What is the ratio of the Number of days in Qatar in 2013 to that in 2015?
Offer a terse response. 1. What is the ratio of the Number of days in Albania in 2014 to that in 2015?
Your answer should be very brief. 1. What is the ratio of the Number of days in Qatar in 2014 to that in 2015?
Provide a succinct answer. 1. What is the difference between the highest and the second highest Number of days in Small states?
Your answer should be compact. 5.62. What is the difference between the highest and the second highest Number of days of Albania?
Offer a very short reply. 0. What is the difference between the highest and the lowest Number of days in Small states?
Provide a short and direct response. 26.08. What is the difference between the highest and the lowest Number of days of Albania?
Your answer should be compact. 135. What is the difference between the highest and the lowest Number of days in Jordan?
Keep it short and to the point. 0. What is the difference between the highest and the lowest Number of days in Qatar?
Provide a short and direct response. 0. 